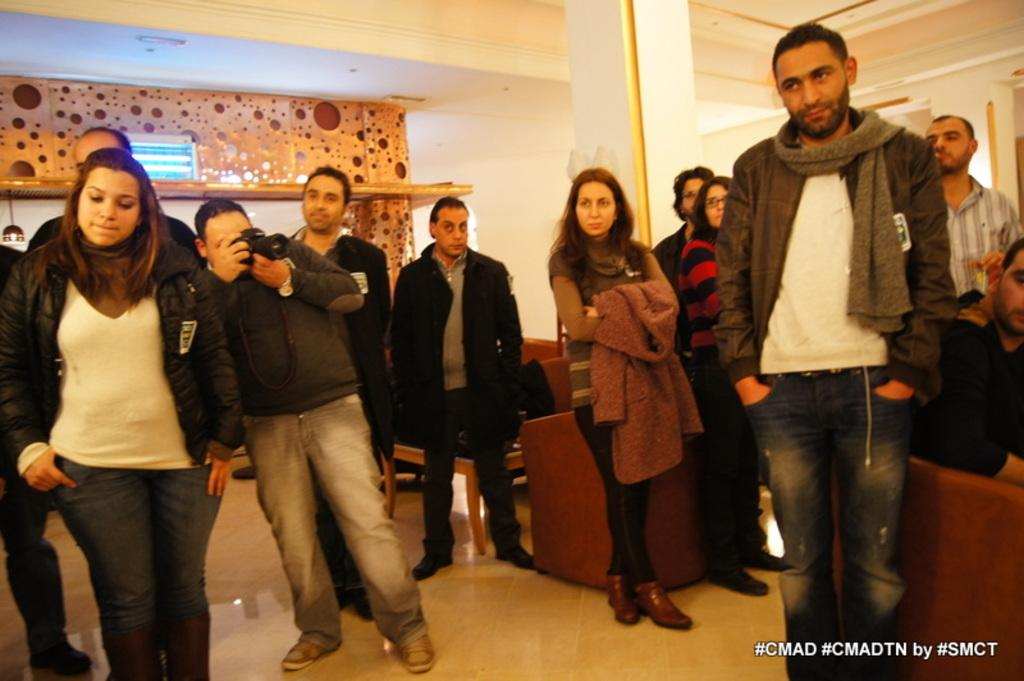<image>
Write a terse but informative summary of the picture. A group of people standing around with #CMAD in the corner. 